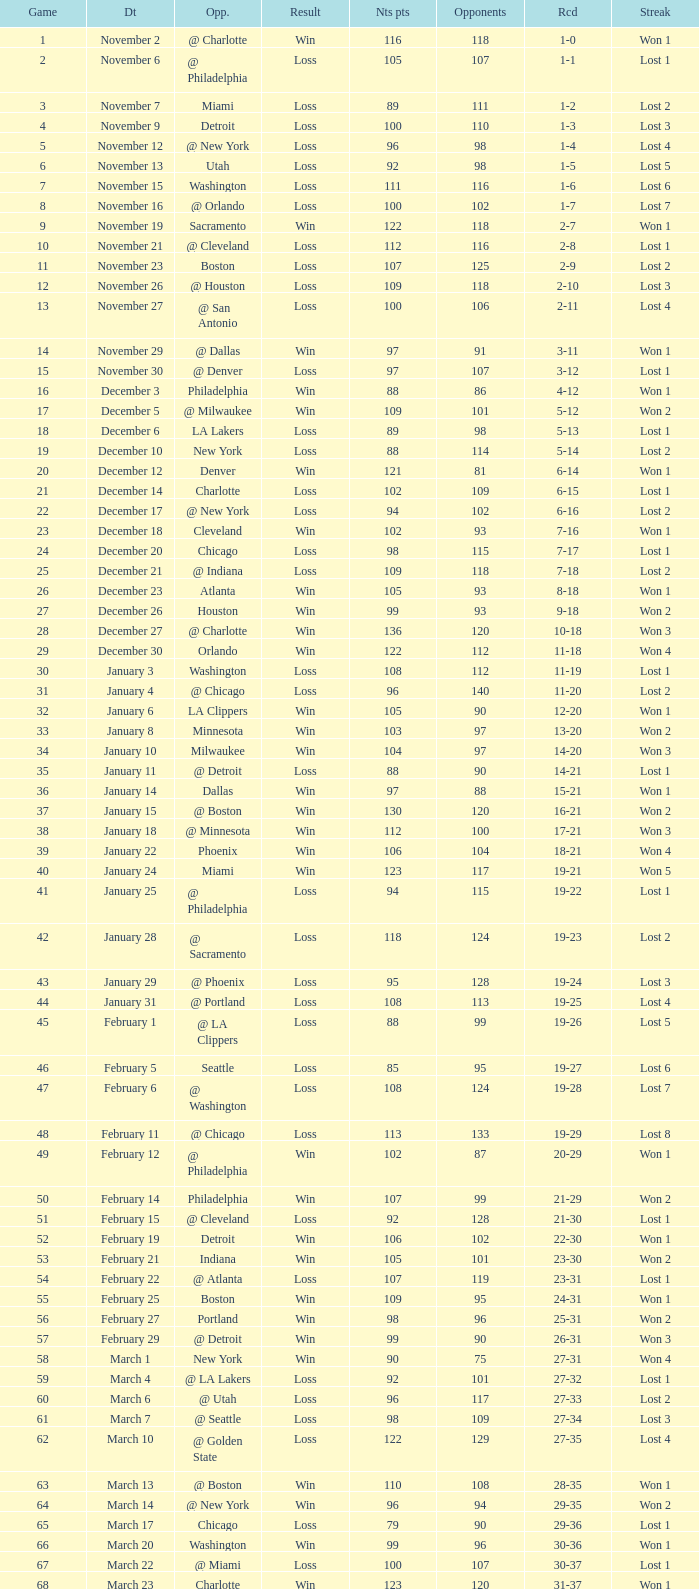Could you parse the entire table? {'header': ['Game', 'Dt', 'Opp.', 'Result', 'Nts pts', 'Opponents', 'Rcd', 'Streak'], 'rows': [['1', 'November 2', '@ Charlotte', 'Win', '116', '118', '1-0', 'Won 1'], ['2', 'November 6', '@ Philadelphia', 'Loss', '105', '107', '1-1', 'Lost 1'], ['3', 'November 7', 'Miami', 'Loss', '89', '111', '1-2', 'Lost 2'], ['4', 'November 9', 'Detroit', 'Loss', '100', '110', '1-3', 'Lost 3'], ['5', 'November 12', '@ New York', 'Loss', '96', '98', '1-4', 'Lost 4'], ['6', 'November 13', 'Utah', 'Loss', '92', '98', '1-5', 'Lost 5'], ['7', 'November 15', 'Washington', 'Loss', '111', '116', '1-6', 'Lost 6'], ['8', 'November 16', '@ Orlando', 'Loss', '100', '102', '1-7', 'Lost 7'], ['9', 'November 19', 'Sacramento', 'Win', '122', '118', '2-7', 'Won 1'], ['10', 'November 21', '@ Cleveland', 'Loss', '112', '116', '2-8', 'Lost 1'], ['11', 'November 23', 'Boston', 'Loss', '107', '125', '2-9', 'Lost 2'], ['12', 'November 26', '@ Houston', 'Loss', '109', '118', '2-10', 'Lost 3'], ['13', 'November 27', '@ San Antonio', 'Loss', '100', '106', '2-11', 'Lost 4'], ['14', 'November 29', '@ Dallas', 'Win', '97', '91', '3-11', 'Won 1'], ['15', 'November 30', '@ Denver', 'Loss', '97', '107', '3-12', 'Lost 1'], ['16', 'December 3', 'Philadelphia', 'Win', '88', '86', '4-12', 'Won 1'], ['17', 'December 5', '@ Milwaukee', 'Win', '109', '101', '5-12', 'Won 2'], ['18', 'December 6', 'LA Lakers', 'Loss', '89', '98', '5-13', 'Lost 1'], ['19', 'December 10', 'New York', 'Loss', '88', '114', '5-14', 'Lost 2'], ['20', 'December 12', 'Denver', 'Win', '121', '81', '6-14', 'Won 1'], ['21', 'December 14', 'Charlotte', 'Loss', '102', '109', '6-15', 'Lost 1'], ['22', 'December 17', '@ New York', 'Loss', '94', '102', '6-16', 'Lost 2'], ['23', 'December 18', 'Cleveland', 'Win', '102', '93', '7-16', 'Won 1'], ['24', 'December 20', 'Chicago', 'Loss', '98', '115', '7-17', 'Lost 1'], ['25', 'December 21', '@ Indiana', 'Loss', '109', '118', '7-18', 'Lost 2'], ['26', 'December 23', 'Atlanta', 'Win', '105', '93', '8-18', 'Won 1'], ['27', 'December 26', 'Houston', 'Win', '99', '93', '9-18', 'Won 2'], ['28', 'December 27', '@ Charlotte', 'Win', '136', '120', '10-18', 'Won 3'], ['29', 'December 30', 'Orlando', 'Win', '122', '112', '11-18', 'Won 4'], ['30', 'January 3', 'Washington', 'Loss', '108', '112', '11-19', 'Lost 1'], ['31', 'January 4', '@ Chicago', 'Loss', '96', '140', '11-20', 'Lost 2'], ['32', 'January 6', 'LA Clippers', 'Win', '105', '90', '12-20', 'Won 1'], ['33', 'January 8', 'Minnesota', 'Win', '103', '97', '13-20', 'Won 2'], ['34', 'January 10', 'Milwaukee', 'Win', '104', '97', '14-20', 'Won 3'], ['35', 'January 11', '@ Detroit', 'Loss', '88', '90', '14-21', 'Lost 1'], ['36', 'January 14', 'Dallas', 'Win', '97', '88', '15-21', 'Won 1'], ['37', 'January 15', '@ Boston', 'Win', '130', '120', '16-21', 'Won 2'], ['38', 'January 18', '@ Minnesota', 'Win', '112', '100', '17-21', 'Won 3'], ['39', 'January 22', 'Phoenix', 'Win', '106', '104', '18-21', 'Won 4'], ['40', 'January 24', 'Miami', 'Win', '123', '117', '19-21', 'Won 5'], ['41', 'January 25', '@ Philadelphia', 'Loss', '94', '115', '19-22', 'Lost 1'], ['42', 'January 28', '@ Sacramento', 'Loss', '118', '124', '19-23', 'Lost 2'], ['43', 'January 29', '@ Phoenix', 'Loss', '95', '128', '19-24', 'Lost 3'], ['44', 'January 31', '@ Portland', 'Loss', '108', '113', '19-25', 'Lost 4'], ['45', 'February 1', '@ LA Clippers', 'Loss', '88', '99', '19-26', 'Lost 5'], ['46', 'February 5', 'Seattle', 'Loss', '85', '95', '19-27', 'Lost 6'], ['47', 'February 6', '@ Washington', 'Loss', '108', '124', '19-28', 'Lost 7'], ['48', 'February 11', '@ Chicago', 'Loss', '113', '133', '19-29', 'Lost 8'], ['49', 'February 12', '@ Philadelphia', 'Win', '102', '87', '20-29', 'Won 1'], ['50', 'February 14', 'Philadelphia', 'Win', '107', '99', '21-29', 'Won 2'], ['51', 'February 15', '@ Cleveland', 'Loss', '92', '128', '21-30', 'Lost 1'], ['52', 'February 19', 'Detroit', 'Win', '106', '102', '22-30', 'Won 1'], ['53', 'February 21', 'Indiana', 'Win', '105', '101', '23-30', 'Won 2'], ['54', 'February 22', '@ Atlanta', 'Loss', '107', '119', '23-31', 'Lost 1'], ['55', 'February 25', 'Boston', 'Win', '109', '95', '24-31', 'Won 1'], ['56', 'February 27', 'Portland', 'Win', '98', '96', '25-31', 'Won 2'], ['57', 'February 29', '@ Detroit', 'Win', '99', '90', '26-31', 'Won 3'], ['58', 'March 1', 'New York', 'Win', '90', '75', '27-31', 'Won 4'], ['59', 'March 4', '@ LA Lakers', 'Loss', '92', '101', '27-32', 'Lost 1'], ['60', 'March 6', '@ Utah', 'Loss', '96', '117', '27-33', 'Lost 2'], ['61', 'March 7', '@ Seattle', 'Loss', '98', '109', '27-34', 'Lost 3'], ['62', 'March 10', '@ Golden State', 'Loss', '122', '129', '27-35', 'Lost 4'], ['63', 'March 13', '@ Boston', 'Win', '110', '108', '28-35', 'Won 1'], ['64', 'March 14', '@ New York', 'Win', '96', '94', '29-35', 'Won 2'], ['65', 'March 17', 'Chicago', 'Loss', '79', '90', '29-36', 'Lost 1'], ['66', 'March 20', 'Washington', 'Win', '99', '96', '30-36', 'Won 1'], ['67', 'March 22', '@ Miami', 'Loss', '100', '107', '30-37', 'Lost 1'], ['68', 'March 23', 'Charlotte', 'Win', '123', '120', '31-37', 'Won 1'], ['69', 'March 25', 'Boston', 'Loss', '110', '118', '31-38', 'Lost 1'], ['70', 'March 28', 'Golden State', 'Loss', '148', '153', '31-39', 'Lost 2'], ['71', 'March 30', 'San Antonio', 'Win', '117', '109', '32-39', 'Won 1'], ['72', 'April 1', '@ Milwaukee', 'Win', '121', '117', '33-39', 'Won 2'], ['73', 'April 3', 'Milwaukee', 'Win', '122', '103', '34-39', 'Won 3'], ['74', 'April 5', '@ Indiana', 'Win', '128', '120', '35-39', 'Won 4'], ['75', 'April 7', 'Atlanta', 'Loss', '97', '104', '35-40', 'Lost 1'], ['76', 'April 8', '@ Washington', 'Win', '109', '103', '36-40', 'Won 1'], ['77', 'April 10', 'Cleveland', 'Win', '110', '86', '37-40', 'Won 2'], ['78', 'April 11', '@ Atlanta', 'Loss', '98', '118', '37-41', 'Lost 1'], ['79', 'April 13', '@ Orlando', 'Win', '110', '104', '38-41', 'Won 1'], ['80', 'April 14', '@ Miami', 'Win', '105', '100', '39-41', 'Won 2'], ['81', 'April 16', 'Indiana', 'Loss', '113', '119', '39-42', 'Lost 1'], ['82', 'April 18', 'Orlando', 'Win', '127', '111', '40-42', 'Won 1'], ['1', 'April 23', '@ Cleveland', 'Loss', '113', '120', '0-1', 'Lost 1'], ['2', 'April 25', '@ Cleveland', 'Loss', '96', '118', '0-2', 'Lost 2'], ['3', 'April 28', 'Cleveland', 'Win', '109', '104', '1-2', 'Won 1'], ['4', 'April 30', 'Cleveland', 'Loss', '89', '98', '1-3', 'Lost 1']]} Which opponent is from february 12? @ Philadelphia. 